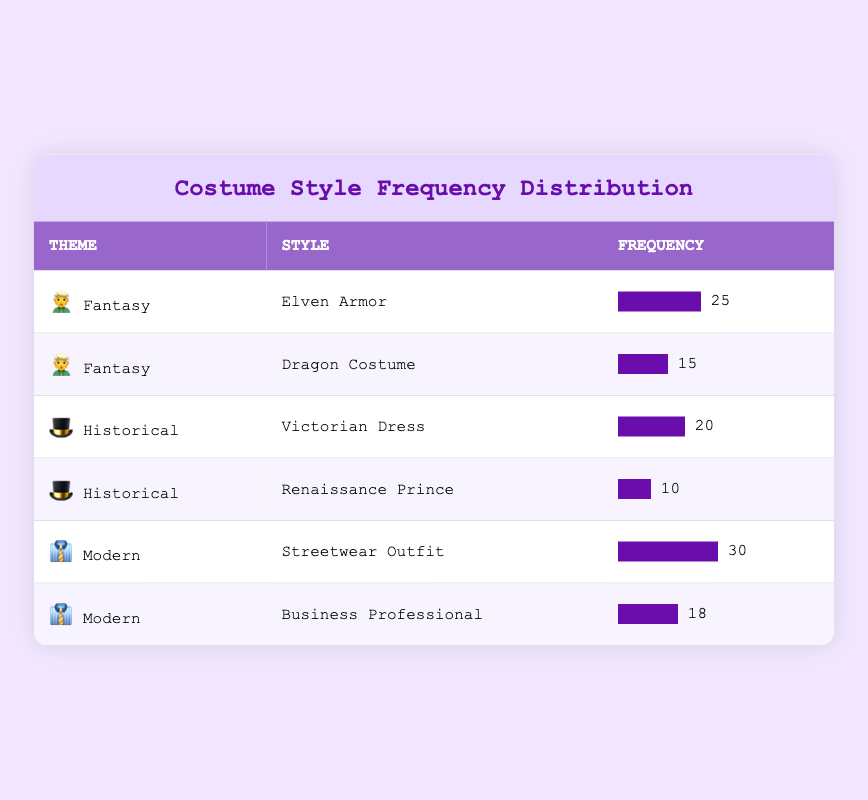What's the frequency of the Elven Armor costume style? The table lists the Elven Armor under the Fantasy theme with a corresponding frequency of 25.
Answer: 25 Which theme has the highest number of costume styles created? The themes in the table are Fantasy, Historical, and Modern. Fantasy has 2 styles, Historical has 2 styles, and Modern has 2 styles, so they are tied in terms of the number of styles created.
Answer: They are tied What is the total frequency of costumes for the Historical theme? The Historical theme has a Victorian Dress with a frequency of 20 and a Renaissance Prince with a frequency of 10. Therefore, the total frequency is 20 + 10 = 30.
Answer: 30 Is the frequency of the Streetwear Outfit higher than the frequency of the Dragon Costume? The frequency of the Streetwear Outfit is 30, while the Dragon Costume has a frequency of 15. Since 30 is greater than 15, the statement is true.
Answer: Yes What is the average frequency of costume styles across all themes? The frequencies are: 25, 15, 20, 10, 30, and 18. The sum of these values is 25 + 15 + 20 + 10 + 30 + 18 = 118. There are 6 styles, so the average frequency is 118 / 6 = 19.67.
Answer: 19.67 Which costume style has the lowest frequency, and what is its value? The table shows that the Renaissance Prince has the lowest frequency at 10.
Answer: Renaissance Prince, 10 What is the difference in frequency between the Streetwear Outfit and the Business Professional costume styles? The frequency of the Streetwear Outfit is 30, while the frequency of the Business Professional is 18. The difference is 30 - 18 = 12.
Answer: 12 Are there more fantasy costume styles than historical costume styles? Both Fantasy and Historical themes have 2 costume styles each listed in the table, indicating they are equal in count.
Answer: No 